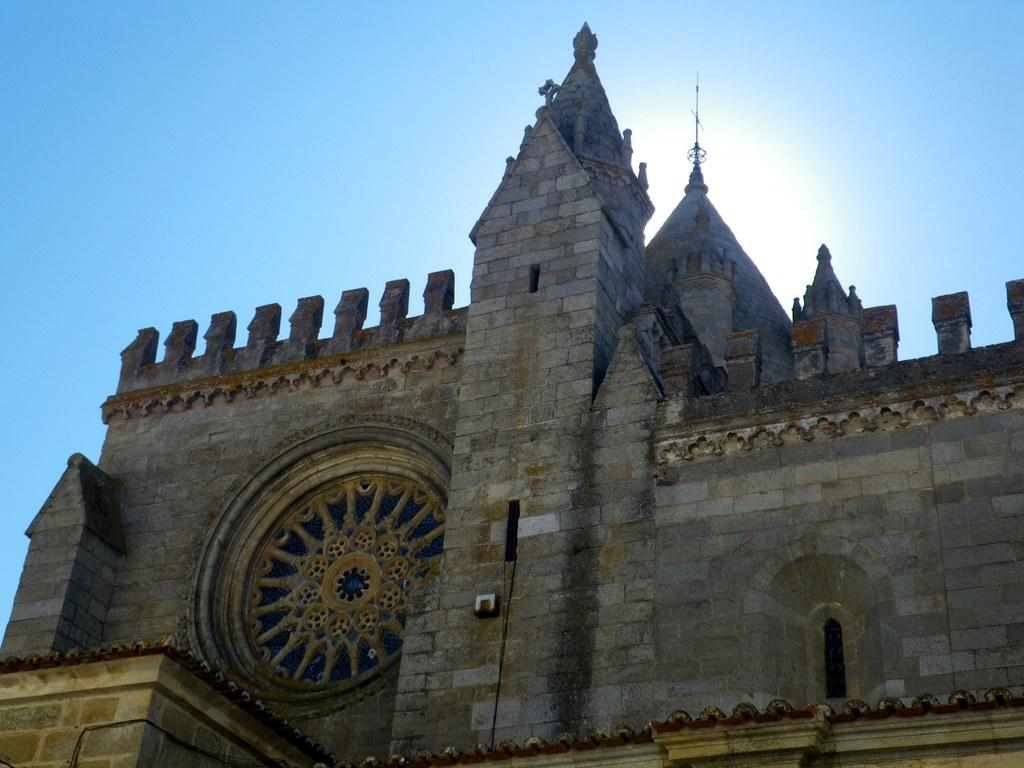What type of structure is visible in the image? There is a building in the image. What material is the building made of? The building is made up of stone bricks. What is the condition of the sky in the image? The sky is clear in the image. What type of jam is being spread on the brother's sandwich in the image? There is no sandwich or jam present in the image; it only features a building made of stone bricks with a clear sky. 